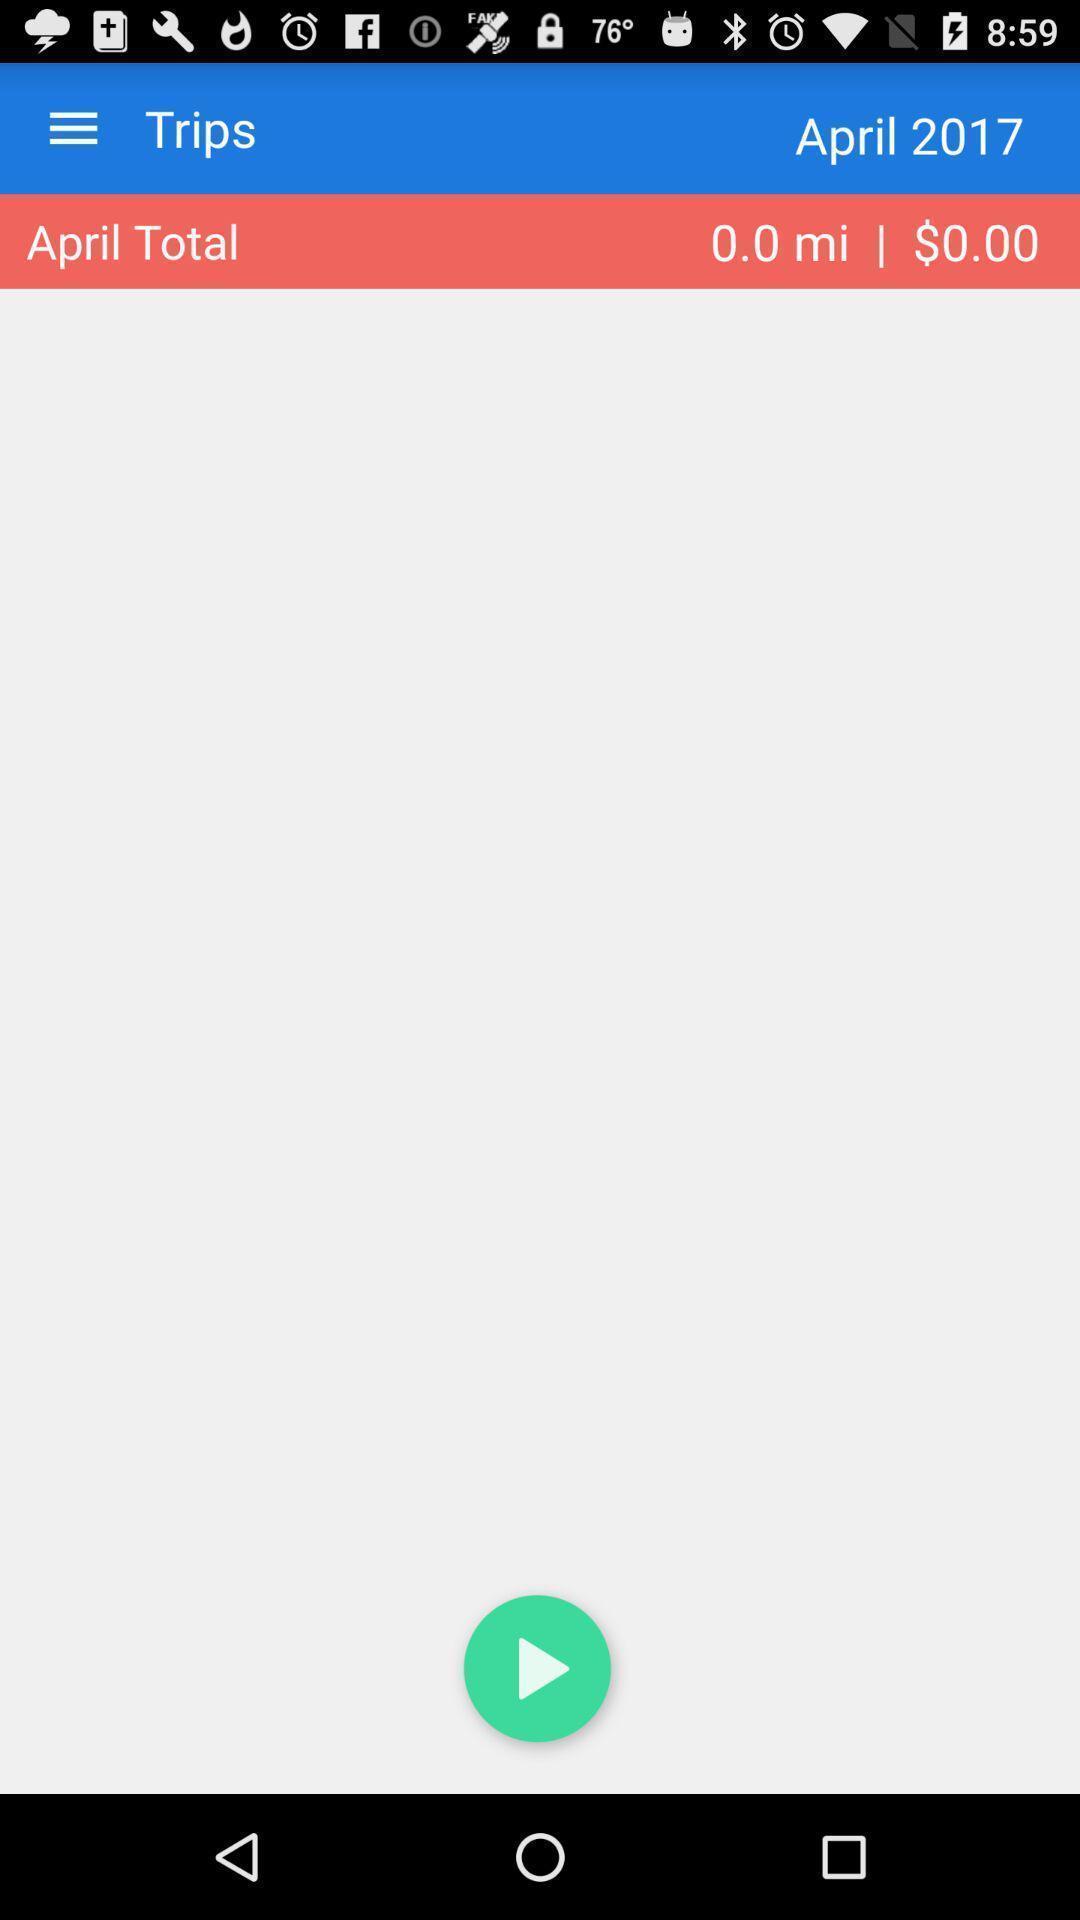Give me a summary of this screen capture. Page of a travel app showing the total amount. 